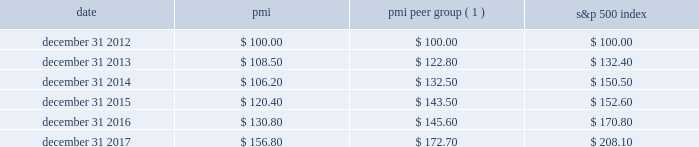Performance graph the graph below compares the cumulative total shareholder return on pmi's common stock with the cumulative total return for the same period of pmi's peer group and the s&p 500 index .
The graph assumes the investment of $ 100 as of december 31 , 2012 , in pmi common stock ( at prices quoted on the new york stock exchange ) and each of the indices as of the market close and reinvestment of dividends on a quarterly basis .
Date pmi pmi peer group ( 1 ) s&p 500 index .
( 1 ) the pmi peer group presented in this graph is the same as that used in the prior year , except reynolds american inc .
Was removed following the completion of its acquisition by british american tobacco p.l.c .
On july 25 , 2017 .
The pmi peer group was established based on a review of four characteristics : global presence ; a focus on consumer products ; and net revenues and a market capitalization of a similar size to those of pmi .
The review also considered the primary international tobacco companies .
As a result of this review , the following companies constitute the pmi peer group : altria group , inc. , anheuser-busch inbev sa/nv , british american tobacco p.l.c. , the coca-cola company , colgate-palmolive co. , diageo plc , heineken n.v. , imperial brands plc , japan tobacco inc. , johnson & johnson , kimberly-clark corporation , the kraft-heinz company , mcdonald's corp. , mondel z international , inc. , nestl e9 s.a. , pepsico , inc. , the procter & gamble company , roche holding ag , and unilever nv and plc .
Note : figures are rounded to the nearest $ 0.10. .
What is the growth rate in pmi's share price from 2012 to 2013? 
Computations: ((108.50 - 100) / 100)
Answer: 0.085. 